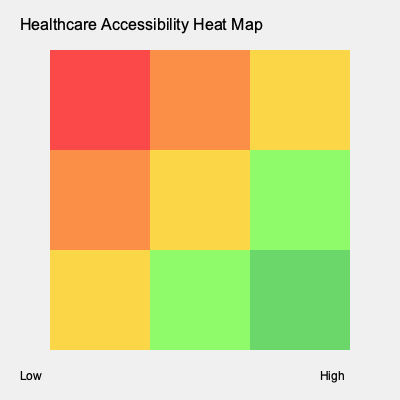Based on the heat map of healthcare accessibility in rural areas, which region shows the highest level of healthcare accessibility, and what strategy would you recommend to improve accessibility in the least accessible areas? 1. Interpret the heat map:
   - Red indicates low accessibility
   - Orange and yellow indicate moderate accessibility
   - Green indicates high accessibility

2. Identify the region with highest accessibility:
   - The bottom-right corner (southeast) shows the darkest green, indicating the highest level of healthcare accessibility.

3. Identify the least accessible areas:
   - The top-left corner (northwest) shows red, indicating the lowest level of healthcare accessibility.

4. Strategy to improve accessibility in least accessible areas:
   a) Conduct a needs assessment to understand specific barriers (e.g., distance, transportation, healthcare provider shortage).
   b) Implement mobile health clinics to reach remote areas.
   c) Develop telemedicine programs to connect patients with healthcare providers remotely.
   d) Offer incentives for healthcare providers to work in underserved areas.
   e) Improve transportation infrastructure to facilitate access to existing healthcare facilities.
   f) Partner with local community organizations to provide health education and preventive care services.

5. Recommend a comprehensive approach:
   Combine multiple strategies to address various aspects of healthcare accessibility, focusing on both short-term solutions (mobile clinics, telemedicine) and long-term improvements (infrastructure, workforce development).
Answer: Southeast region; implement mobile clinics, telemedicine, provider incentives, and improve infrastructure. 